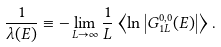Convert formula to latex. <formula><loc_0><loc_0><loc_500><loc_500>\frac { 1 } { \lambda ( E ) } \equiv - \lim _ { L \rightarrow \infty } \frac { 1 } { L } \left < \ln \left | G ^ { 0 , 0 } _ { 1 L } ( E ) \right | \right > .</formula> 